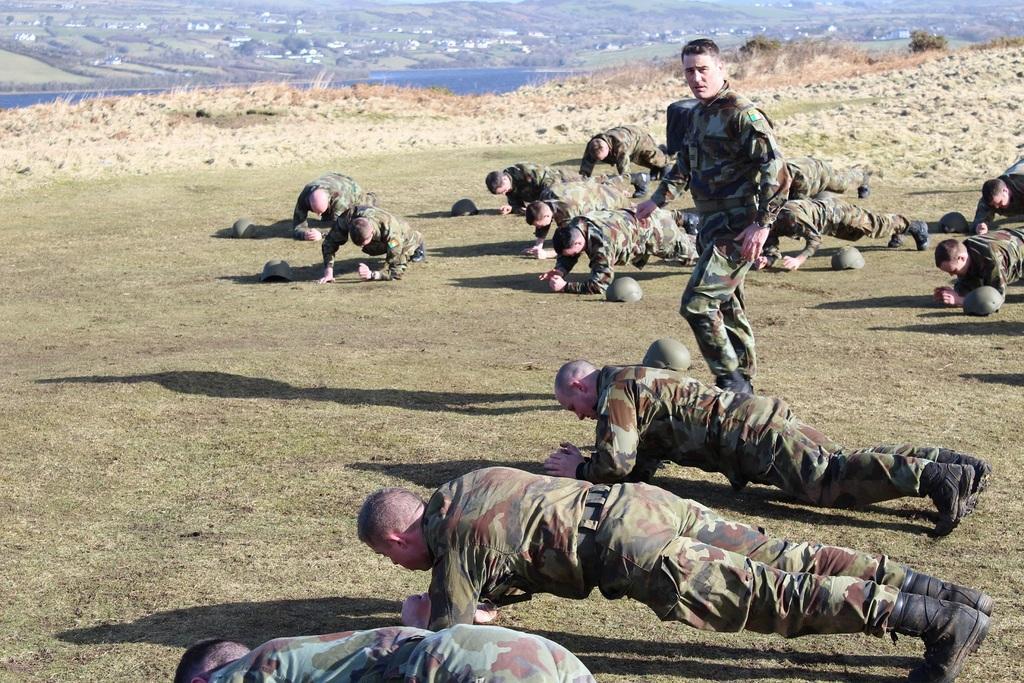How would you summarize this image in a sentence or two? In this picture there are group of people exercising and there is a man walking. At the back there are buildings and trees and there is water. At the bottom there are plants and there are helmets and there's grass on the ground. 